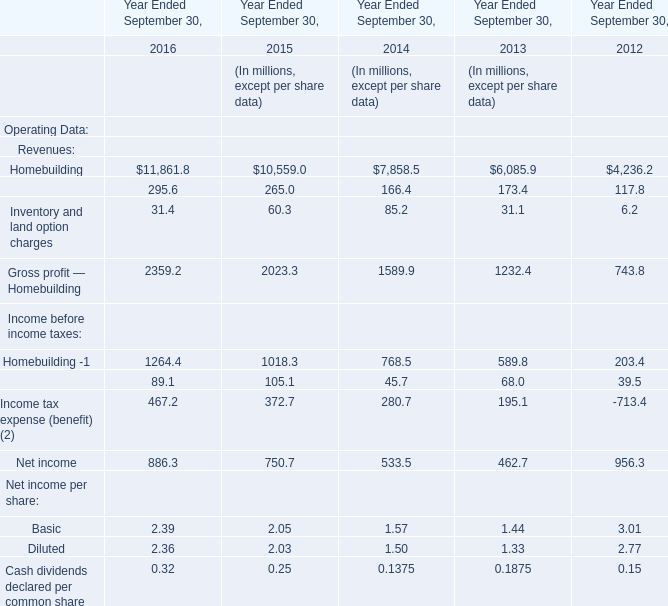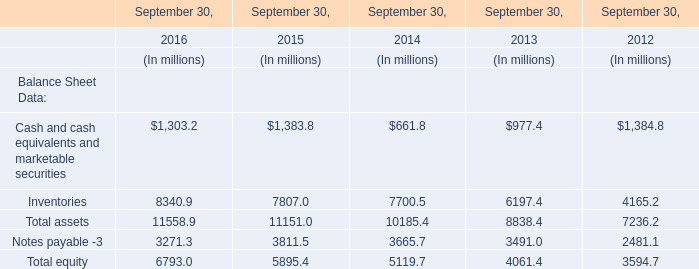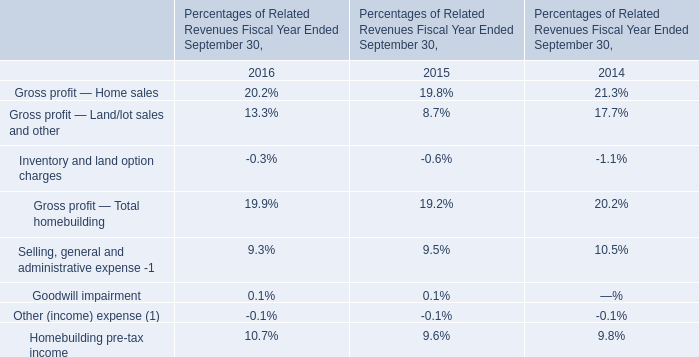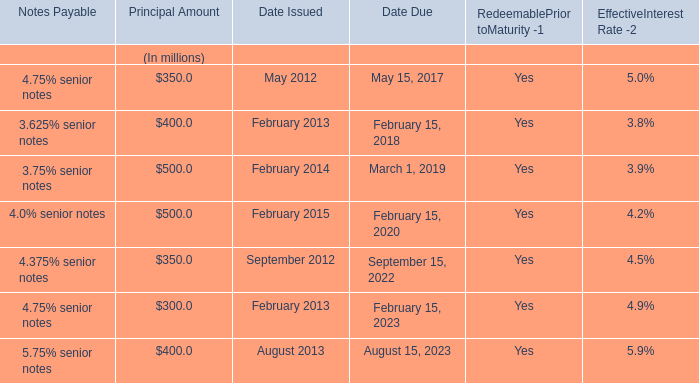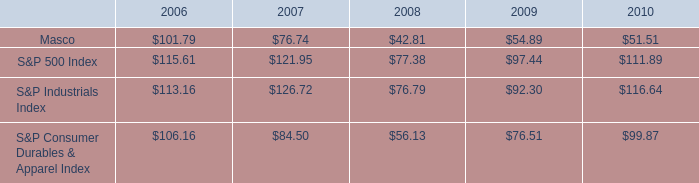In which year is Inventory and land option charges smaller than Financial Services ? 
Answer: 2012 2013 2014 2015 2016. 